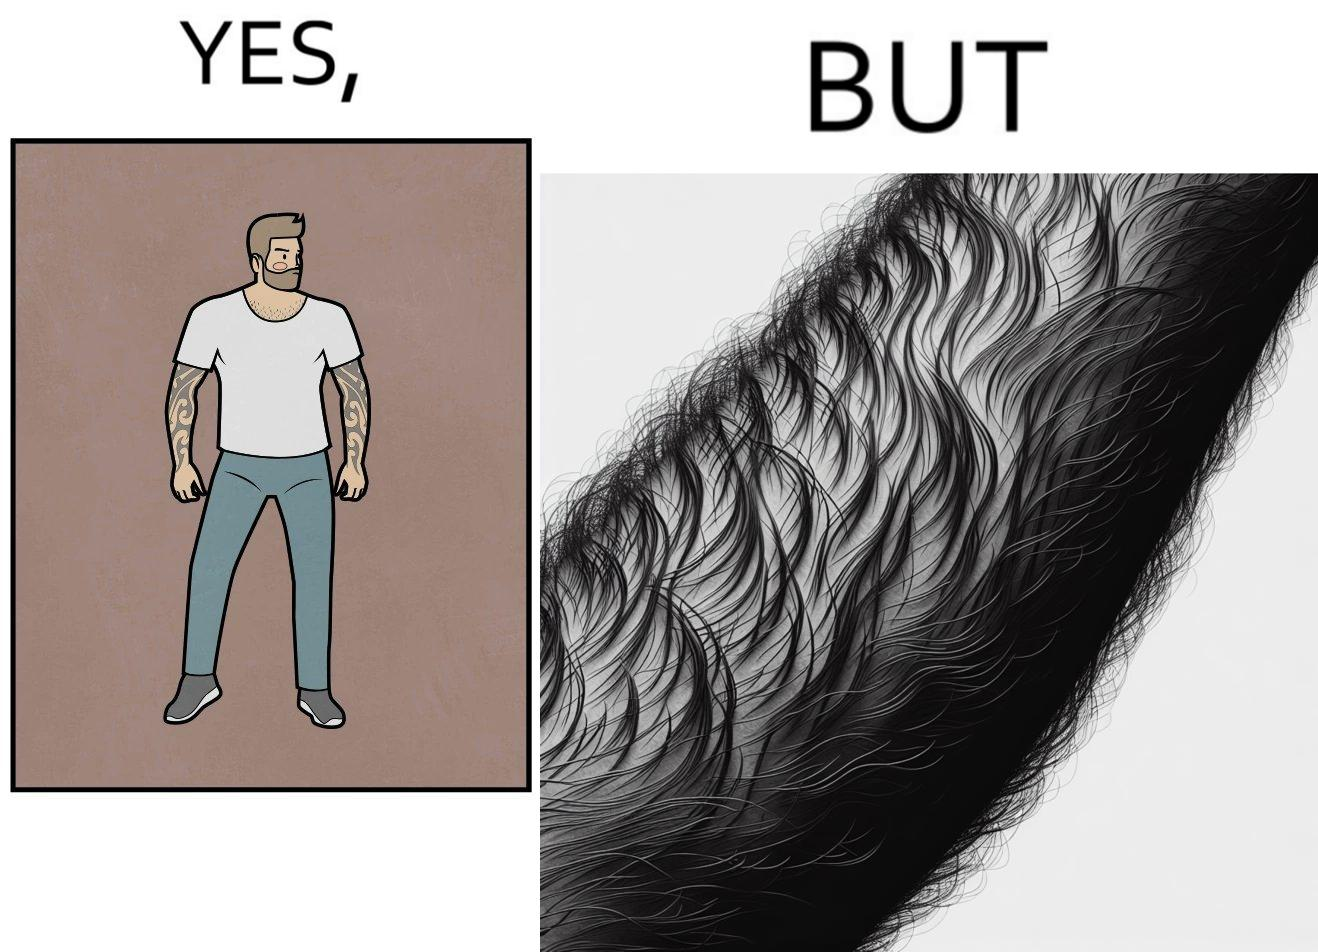What is shown in this image? The image is funny because while from the distance it seems that the man has big tattoos on both of his arms upon a closer look at the arms it turns out there is no tattoo and what seemed to be tattoos are just hairs on his arm. 